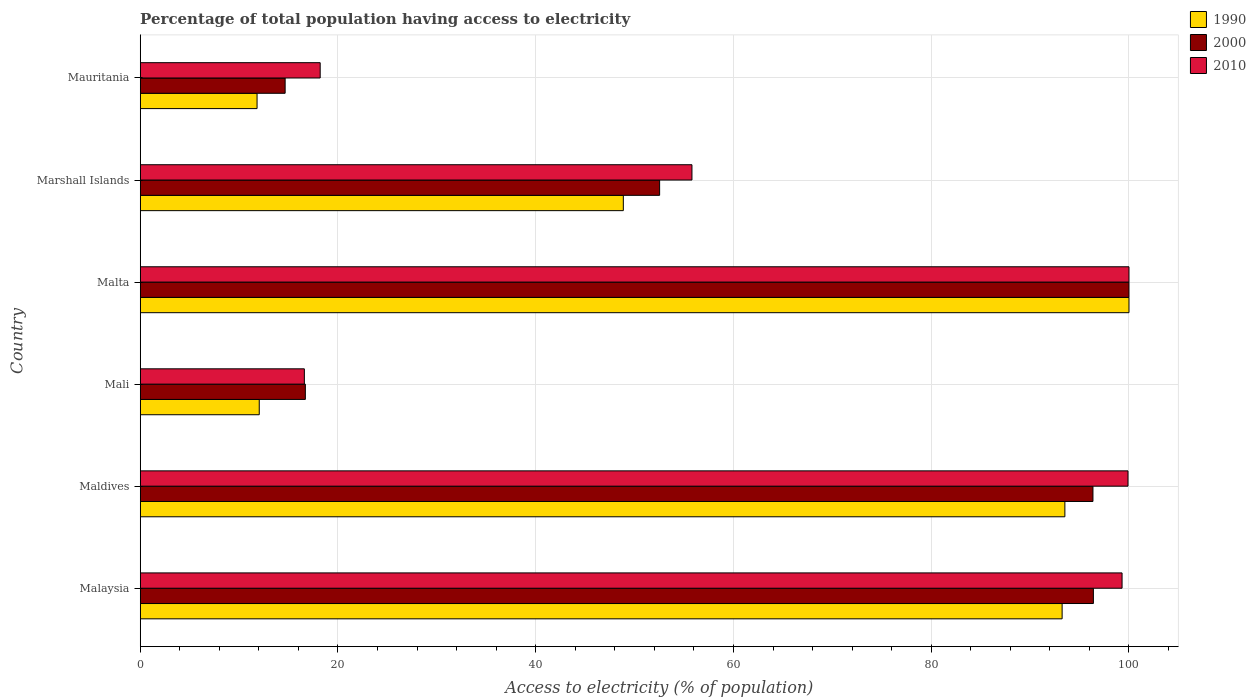What is the label of the 6th group of bars from the top?
Ensure brevity in your answer.  Malaysia. Across all countries, what is the maximum percentage of population that have access to electricity in 1990?
Your answer should be compact. 100. Across all countries, what is the minimum percentage of population that have access to electricity in 2000?
Give a very brief answer. 14.66. In which country was the percentage of population that have access to electricity in 2010 maximum?
Make the answer very short. Malta. In which country was the percentage of population that have access to electricity in 2010 minimum?
Make the answer very short. Mali. What is the total percentage of population that have access to electricity in 1990 in the graph?
Give a very brief answer. 359.47. What is the difference between the percentage of population that have access to electricity in 2010 in Marshall Islands and that in Mauritania?
Keep it short and to the point. 37.6. What is the difference between the percentage of population that have access to electricity in 2000 in Marshall Islands and the percentage of population that have access to electricity in 2010 in Maldives?
Make the answer very short. -47.37. What is the average percentage of population that have access to electricity in 2000 per country?
Make the answer very short. 62.77. What is the difference between the percentage of population that have access to electricity in 2010 and percentage of population that have access to electricity in 2000 in Malaysia?
Make the answer very short. 2.9. What is the ratio of the percentage of population that have access to electricity in 2010 in Malta to that in Marshall Islands?
Your response must be concise. 1.79. Is the difference between the percentage of population that have access to electricity in 2010 in Malta and Mauritania greater than the difference between the percentage of population that have access to electricity in 2000 in Malta and Mauritania?
Provide a succinct answer. No. What is the difference between the highest and the second highest percentage of population that have access to electricity in 1990?
Provide a short and direct response. 6.48. What is the difference between the highest and the lowest percentage of population that have access to electricity in 2000?
Ensure brevity in your answer.  85.34. In how many countries, is the percentage of population that have access to electricity in 1990 greater than the average percentage of population that have access to electricity in 1990 taken over all countries?
Your answer should be compact. 3. What does the 3rd bar from the bottom in Maldives represents?
Your answer should be very brief. 2010. Is it the case that in every country, the sum of the percentage of population that have access to electricity in 2010 and percentage of population that have access to electricity in 1990 is greater than the percentage of population that have access to electricity in 2000?
Offer a very short reply. Yes. Are all the bars in the graph horizontal?
Make the answer very short. Yes. What is the difference between two consecutive major ticks on the X-axis?
Your answer should be compact. 20. Are the values on the major ticks of X-axis written in scientific E-notation?
Make the answer very short. No. Does the graph contain grids?
Your answer should be very brief. Yes. How many legend labels are there?
Ensure brevity in your answer.  3. What is the title of the graph?
Give a very brief answer. Percentage of total population having access to electricity. What is the label or title of the X-axis?
Your answer should be very brief. Access to electricity (% of population). What is the label or title of the Y-axis?
Your response must be concise. Country. What is the Access to electricity (% of population) in 1990 in Malaysia?
Offer a very short reply. 93.24. What is the Access to electricity (% of population) of 2000 in Malaysia?
Offer a very short reply. 96.4. What is the Access to electricity (% of population) in 2010 in Malaysia?
Give a very brief answer. 99.3. What is the Access to electricity (% of population) of 1990 in Maldives?
Make the answer very short. 93.52. What is the Access to electricity (% of population) in 2000 in Maldives?
Make the answer very short. 96.36. What is the Access to electricity (% of population) of 2010 in Maldives?
Your answer should be compact. 99.9. What is the Access to electricity (% of population) of 1990 in Mali?
Offer a very short reply. 12.04. What is the Access to electricity (% of population) of 2010 in Mali?
Your answer should be very brief. 16.6. What is the Access to electricity (% of population) of 1990 in Malta?
Offer a terse response. 100. What is the Access to electricity (% of population) in 2010 in Malta?
Provide a short and direct response. 100. What is the Access to electricity (% of population) of 1990 in Marshall Islands?
Make the answer very short. 48.86. What is the Access to electricity (% of population) of 2000 in Marshall Islands?
Provide a short and direct response. 52.53. What is the Access to electricity (% of population) of 2010 in Marshall Islands?
Your answer should be compact. 55.8. What is the Access to electricity (% of population) of 1990 in Mauritania?
Make the answer very short. 11.82. What is the Access to electricity (% of population) of 2000 in Mauritania?
Ensure brevity in your answer.  14.66. Across all countries, what is the maximum Access to electricity (% of population) of 1990?
Your answer should be very brief. 100. Across all countries, what is the minimum Access to electricity (% of population) in 1990?
Give a very brief answer. 11.82. Across all countries, what is the minimum Access to electricity (% of population) in 2000?
Your answer should be very brief. 14.66. What is the total Access to electricity (% of population) of 1990 in the graph?
Ensure brevity in your answer.  359.47. What is the total Access to electricity (% of population) of 2000 in the graph?
Ensure brevity in your answer.  376.64. What is the total Access to electricity (% of population) in 2010 in the graph?
Your response must be concise. 389.8. What is the difference between the Access to electricity (% of population) of 1990 in Malaysia and that in Maldives?
Ensure brevity in your answer.  -0.28. What is the difference between the Access to electricity (% of population) of 2000 in Malaysia and that in Maldives?
Ensure brevity in your answer.  0.04. What is the difference between the Access to electricity (% of population) in 1990 in Malaysia and that in Mali?
Give a very brief answer. 81.2. What is the difference between the Access to electricity (% of population) in 2000 in Malaysia and that in Mali?
Your answer should be compact. 79.7. What is the difference between the Access to electricity (% of population) of 2010 in Malaysia and that in Mali?
Ensure brevity in your answer.  82.7. What is the difference between the Access to electricity (% of population) of 1990 in Malaysia and that in Malta?
Provide a succinct answer. -6.76. What is the difference between the Access to electricity (% of population) of 2000 in Malaysia and that in Malta?
Give a very brief answer. -3.6. What is the difference between the Access to electricity (% of population) of 2010 in Malaysia and that in Malta?
Offer a very short reply. -0.7. What is the difference between the Access to electricity (% of population) of 1990 in Malaysia and that in Marshall Islands?
Your response must be concise. 44.38. What is the difference between the Access to electricity (% of population) in 2000 in Malaysia and that in Marshall Islands?
Your answer should be compact. 43.87. What is the difference between the Access to electricity (% of population) in 2010 in Malaysia and that in Marshall Islands?
Ensure brevity in your answer.  43.5. What is the difference between the Access to electricity (% of population) in 1990 in Malaysia and that in Mauritania?
Your answer should be very brief. 81.42. What is the difference between the Access to electricity (% of population) of 2000 in Malaysia and that in Mauritania?
Make the answer very short. 81.74. What is the difference between the Access to electricity (% of population) in 2010 in Malaysia and that in Mauritania?
Make the answer very short. 81.1. What is the difference between the Access to electricity (% of population) of 1990 in Maldives and that in Mali?
Your answer should be compact. 81.48. What is the difference between the Access to electricity (% of population) of 2000 in Maldives and that in Mali?
Offer a very short reply. 79.66. What is the difference between the Access to electricity (% of population) in 2010 in Maldives and that in Mali?
Your response must be concise. 83.3. What is the difference between the Access to electricity (% of population) of 1990 in Maldives and that in Malta?
Give a very brief answer. -6.48. What is the difference between the Access to electricity (% of population) of 2000 in Maldives and that in Malta?
Offer a very short reply. -3.64. What is the difference between the Access to electricity (% of population) of 1990 in Maldives and that in Marshall Islands?
Make the answer very short. 44.66. What is the difference between the Access to electricity (% of population) of 2000 in Maldives and that in Marshall Islands?
Your response must be concise. 43.83. What is the difference between the Access to electricity (% of population) in 2010 in Maldives and that in Marshall Islands?
Give a very brief answer. 44.1. What is the difference between the Access to electricity (% of population) of 1990 in Maldives and that in Mauritania?
Your answer should be very brief. 81.7. What is the difference between the Access to electricity (% of population) of 2000 in Maldives and that in Mauritania?
Offer a very short reply. 81.7. What is the difference between the Access to electricity (% of population) of 2010 in Maldives and that in Mauritania?
Offer a terse response. 81.7. What is the difference between the Access to electricity (% of population) in 1990 in Mali and that in Malta?
Make the answer very short. -87.96. What is the difference between the Access to electricity (% of population) in 2000 in Mali and that in Malta?
Give a very brief answer. -83.3. What is the difference between the Access to electricity (% of population) of 2010 in Mali and that in Malta?
Offer a very short reply. -83.4. What is the difference between the Access to electricity (% of population) in 1990 in Mali and that in Marshall Islands?
Your response must be concise. -36.82. What is the difference between the Access to electricity (% of population) of 2000 in Mali and that in Marshall Islands?
Offer a terse response. -35.83. What is the difference between the Access to electricity (% of population) of 2010 in Mali and that in Marshall Islands?
Your answer should be compact. -39.2. What is the difference between the Access to electricity (% of population) of 1990 in Mali and that in Mauritania?
Your answer should be very brief. 0.22. What is the difference between the Access to electricity (% of population) of 2000 in Mali and that in Mauritania?
Offer a very short reply. 2.04. What is the difference between the Access to electricity (% of population) in 2010 in Mali and that in Mauritania?
Your response must be concise. -1.6. What is the difference between the Access to electricity (% of population) of 1990 in Malta and that in Marshall Islands?
Give a very brief answer. 51.14. What is the difference between the Access to electricity (% of population) of 2000 in Malta and that in Marshall Islands?
Ensure brevity in your answer.  47.47. What is the difference between the Access to electricity (% of population) in 2010 in Malta and that in Marshall Islands?
Make the answer very short. 44.2. What is the difference between the Access to electricity (% of population) in 1990 in Malta and that in Mauritania?
Your response must be concise. 88.18. What is the difference between the Access to electricity (% of population) of 2000 in Malta and that in Mauritania?
Offer a terse response. 85.34. What is the difference between the Access to electricity (% of population) in 2010 in Malta and that in Mauritania?
Keep it short and to the point. 81.8. What is the difference between the Access to electricity (% of population) in 1990 in Marshall Islands and that in Mauritania?
Keep it short and to the point. 37.04. What is the difference between the Access to electricity (% of population) in 2000 in Marshall Islands and that in Mauritania?
Make the answer very short. 37.87. What is the difference between the Access to electricity (% of population) in 2010 in Marshall Islands and that in Mauritania?
Give a very brief answer. 37.6. What is the difference between the Access to electricity (% of population) of 1990 in Malaysia and the Access to electricity (% of population) of 2000 in Maldives?
Provide a short and direct response. -3.12. What is the difference between the Access to electricity (% of population) in 1990 in Malaysia and the Access to electricity (% of population) in 2010 in Maldives?
Offer a terse response. -6.66. What is the difference between the Access to electricity (% of population) in 1990 in Malaysia and the Access to electricity (% of population) in 2000 in Mali?
Ensure brevity in your answer.  76.54. What is the difference between the Access to electricity (% of population) in 1990 in Malaysia and the Access to electricity (% of population) in 2010 in Mali?
Ensure brevity in your answer.  76.64. What is the difference between the Access to electricity (% of population) in 2000 in Malaysia and the Access to electricity (% of population) in 2010 in Mali?
Provide a short and direct response. 79.8. What is the difference between the Access to electricity (% of population) of 1990 in Malaysia and the Access to electricity (% of population) of 2000 in Malta?
Provide a succinct answer. -6.76. What is the difference between the Access to electricity (% of population) of 1990 in Malaysia and the Access to electricity (% of population) of 2010 in Malta?
Ensure brevity in your answer.  -6.76. What is the difference between the Access to electricity (% of population) in 1990 in Malaysia and the Access to electricity (% of population) in 2000 in Marshall Islands?
Provide a succinct answer. 40.71. What is the difference between the Access to electricity (% of population) of 1990 in Malaysia and the Access to electricity (% of population) of 2010 in Marshall Islands?
Provide a short and direct response. 37.44. What is the difference between the Access to electricity (% of population) of 2000 in Malaysia and the Access to electricity (% of population) of 2010 in Marshall Islands?
Offer a very short reply. 40.6. What is the difference between the Access to electricity (% of population) of 1990 in Malaysia and the Access to electricity (% of population) of 2000 in Mauritania?
Keep it short and to the point. 78.58. What is the difference between the Access to electricity (% of population) in 1990 in Malaysia and the Access to electricity (% of population) in 2010 in Mauritania?
Provide a succinct answer. 75.04. What is the difference between the Access to electricity (% of population) of 2000 in Malaysia and the Access to electricity (% of population) of 2010 in Mauritania?
Offer a very short reply. 78.2. What is the difference between the Access to electricity (% of population) in 1990 in Maldives and the Access to electricity (% of population) in 2000 in Mali?
Your response must be concise. 76.82. What is the difference between the Access to electricity (% of population) in 1990 in Maldives and the Access to electricity (% of population) in 2010 in Mali?
Provide a succinct answer. 76.92. What is the difference between the Access to electricity (% of population) of 2000 in Maldives and the Access to electricity (% of population) of 2010 in Mali?
Give a very brief answer. 79.76. What is the difference between the Access to electricity (% of population) in 1990 in Maldives and the Access to electricity (% of population) in 2000 in Malta?
Provide a short and direct response. -6.48. What is the difference between the Access to electricity (% of population) in 1990 in Maldives and the Access to electricity (% of population) in 2010 in Malta?
Offer a terse response. -6.48. What is the difference between the Access to electricity (% of population) of 2000 in Maldives and the Access to electricity (% of population) of 2010 in Malta?
Offer a terse response. -3.64. What is the difference between the Access to electricity (% of population) of 1990 in Maldives and the Access to electricity (% of population) of 2000 in Marshall Islands?
Keep it short and to the point. 40.99. What is the difference between the Access to electricity (% of population) of 1990 in Maldives and the Access to electricity (% of population) of 2010 in Marshall Islands?
Ensure brevity in your answer.  37.72. What is the difference between the Access to electricity (% of population) of 2000 in Maldives and the Access to electricity (% of population) of 2010 in Marshall Islands?
Give a very brief answer. 40.56. What is the difference between the Access to electricity (% of population) of 1990 in Maldives and the Access to electricity (% of population) of 2000 in Mauritania?
Provide a succinct answer. 78.86. What is the difference between the Access to electricity (% of population) of 1990 in Maldives and the Access to electricity (% of population) of 2010 in Mauritania?
Your response must be concise. 75.32. What is the difference between the Access to electricity (% of population) in 2000 in Maldives and the Access to electricity (% of population) in 2010 in Mauritania?
Your answer should be very brief. 78.16. What is the difference between the Access to electricity (% of population) in 1990 in Mali and the Access to electricity (% of population) in 2000 in Malta?
Make the answer very short. -87.96. What is the difference between the Access to electricity (% of population) in 1990 in Mali and the Access to electricity (% of population) in 2010 in Malta?
Make the answer very short. -87.96. What is the difference between the Access to electricity (% of population) in 2000 in Mali and the Access to electricity (% of population) in 2010 in Malta?
Your response must be concise. -83.3. What is the difference between the Access to electricity (% of population) in 1990 in Mali and the Access to electricity (% of population) in 2000 in Marshall Islands?
Your answer should be very brief. -40.49. What is the difference between the Access to electricity (% of population) of 1990 in Mali and the Access to electricity (% of population) of 2010 in Marshall Islands?
Provide a succinct answer. -43.76. What is the difference between the Access to electricity (% of population) in 2000 in Mali and the Access to electricity (% of population) in 2010 in Marshall Islands?
Your answer should be compact. -39.1. What is the difference between the Access to electricity (% of population) in 1990 in Mali and the Access to electricity (% of population) in 2000 in Mauritania?
Make the answer very short. -2.62. What is the difference between the Access to electricity (% of population) in 1990 in Mali and the Access to electricity (% of population) in 2010 in Mauritania?
Offer a terse response. -6.16. What is the difference between the Access to electricity (% of population) of 1990 in Malta and the Access to electricity (% of population) of 2000 in Marshall Islands?
Make the answer very short. 47.47. What is the difference between the Access to electricity (% of population) of 1990 in Malta and the Access to electricity (% of population) of 2010 in Marshall Islands?
Offer a terse response. 44.2. What is the difference between the Access to electricity (% of population) of 2000 in Malta and the Access to electricity (% of population) of 2010 in Marshall Islands?
Your answer should be compact. 44.2. What is the difference between the Access to electricity (% of population) in 1990 in Malta and the Access to electricity (% of population) in 2000 in Mauritania?
Your response must be concise. 85.34. What is the difference between the Access to electricity (% of population) of 1990 in Malta and the Access to electricity (% of population) of 2010 in Mauritania?
Your response must be concise. 81.8. What is the difference between the Access to electricity (% of population) of 2000 in Malta and the Access to electricity (% of population) of 2010 in Mauritania?
Offer a very short reply. 81.8. What is the difference between the Access to electricity (% of population) of 1990 in Marshall Islands and the Access to electricity (% of population) of 2000 in Mauritania?
Keep it short and to the point. 34.2. What is the difference between the Access to electricity (% of population) in 1990 in Marshall Islands and the Access to electricity (% of population) in 2010 in Mauritania?
Keep it short and to the point. 30.66. What is the difference between the Access to electricity (% of population) in 2000 in Marshall Islands and the Access to electricity (% of population) in 2010 in Mauritania?
Your answer should be compact. 34.33. What is the average Access to electricity (% of population) in 1990 per country?
Provide a succinct answer. 59.91. What is the average Access to electricity (% of population) of 2000 per country?
Your answer should be compact. 62.77. What is the average Access to electricity (% of population) of 2010 per country?
Provide a succinct answer. 64.97. What is the difference between the Access to electricity (% of population) in 1990 and Access to electricity (% of population) in 2000 in Malaysia?
Give a very brief answer. -3.16. What is the difference between the Access to electricity (% of population) in 1990 and Access to electricity (% of population) in 2010 in Malaysia?
Ensure brevity in your answer.  -6.06. What is the difference between the Access to electricity (% of population) of 2000 and Access to electricity (% of population) of 2010 in Malaysia?
Your response must be concise. -2.9. What is the difference between the Access to electricity (% of population) of 1990 and Access to electricity (% of population) of 2000 in Maldives?
Your answer should be very brief. -2.84. What is the difference between the Access to electricity (% of population) of 1990 and Access to electricity (% of population) of 2010 in Maldives?
Your answer should be compact. -6.38. What is the difference between the Access to electricity (% of population) in 2000 and Access to electricity (% of population) in 2010 in Maldives?
Provide a short and direct response. -3.54. What is the difference between the Access to electricity (% of population) in 1990 and Access to electricity (% of population) in 2000 in Mali?
Make the answer very short. -4.66. What is the difference between the Access to electricity (% of population) in 1990 and Access to electricity (% of population) in 2010 in Mali?
Provide a short and direct response. -4.56. What is the difference between the Access to electricity (% of population) in 2000 and Access to electricity (% of population) in 2010 in Mali?
Give a very brief answer. 0.1. What is the difference between the Access to electricity (% of population) in 1990 and Access to electricity (% of population) in 2000 in Malta?
Your answer should be compact. 0. What is the difference between the Access to electricity (% of population) of 1990 and Access to electricity (% of population) of 2010 in Malta?
Your answer should be very brief. 0. What is the difference between the Access to electricity (% of population) of 2000 and Access to electricity (% of population) of 2010 in Malta?
Ensure brevity in your answer.  0. What is the difference between the Access to electricity (% of population) of 1990 and Access to electricity (% of population) of 2000 in Marshall Islands?
Offer a terse response. -3.67. What is the difference between the Access to electricity (% of population) of 1990 and Access to electricity (% of population) of 2010 in Marshall Islands?
Your response must be concise. -6.94. What is the difference between the Access to electricity (% of population) in 2000 and Access to electricity (% of population) in 2010 in Marshall Islands?
Provide a short and direct response. -3.27. What is the difference between the Access to electricity (% of population) in 1990 and Access to electricity (% of population) in 2000 in Mauritania?
Your response must be concise. -2.84. What is the difference between the Access to electricity (% of population) in 1990 and Access to electricity (% of population) in 2010 in Mauritania?
Give a very brief answer. -6.38. What is the difference between the Access to electricity (% of population) of 2000 and Access to electricity (% of population) of 2010 in Mauritania?
Ensure brevity in your answer.  -3.54. What is the ratio of the Access to electricity (% of population) in 2000 in Malaysia to that in Maldives?
Keep it short and to the point. 1. What is the ratio of the Access to electricity (% of population) of 2010 in Malaysia to that in Maldives?
Keep it short and to the point. 0.99. What is the ratio of the Access to electricity (% of population) in 1990 in Malaysia to that in Mali?
Keep it short and to the point. 7.75. What is the ratio of the Access to electricity (% of population) in 2000 in Malaysia to that in Mali?
Provide a short and direct response. 5.77. What is the ratio of the Access to electricity (% of population) in 2010 in Malaysia to that in Mali?
Provide a short and direct response. 5.98. What is the ratio of the Access to electricity (% of population) in 1990 in Malaysia to that in Malta?
Your response must be concise. 0.93. What is the ratio of the Access to electricity (% of population) in 1990 in Malaysia to that in Marshall Islands?
Ensure brevity in your answer.  1.91. What is the ratio of the Access to electricity (% of population) of 2000 in Malaysia to that in Marshall Islands?
Offer a terse response. 1.84. What is the ratio of the Access to electricity (% of population) in 2010 in Malaysia to that in Marshall Islands?
Make the answer very short. 1.78. What is the ratio of the Access to electricity (% of population) of 1990 in Malaysia to that in Mauritania?
Provide a short and direct response. 7.89. What is the ratio of the Access to electricity (% of population) of 2000 in Malaysia to that in Mauritania?
Offer a very short reply. 6.58. What is the ratio of the Access to electricity (% of population) in 2010 in Malaysia to that in Mauritania?
Your answer should be compact. 5.46. What is the ratio of the Access to electricity (% of population) in 1990 in Maldives to that in Mali?
Offer a very short reply. 7.77. What is the ratio of the Access to electricity (% of population) in 2000 in Maldives to that in Mali?
Provide a succinct answer. 5.77. What is the ratio of the Access to electricity (% of population) of 2010 in Maldives to that in Mali?
Give a very brief answer. 6.02. What is the ratio of the Access to electricity (% of population) in 1990 in Maldives to that in Malta?
Give a very brief answer. 0.94. What is the ratio of the Access to electricity (% of population) in 2000 in Maldives to that in Malta?
Offer a very short reply. 0.96. What is the ratio of the Access to electricity (% of population) in 2010 in Maldives to that in Malta?
Offer a terse response. 1. What is the ratio of the Access to electricity (% of population) in 1990 in Maldives to that in Marshall Islands?
Provide a succinct answer. 1.91. What is the ratio of the Access to electricity (% of population) of 2000 in Maldives to that in Marshall Islands?
Offer a very short reply. 1.83. What is the ratio of the Access to electricity (% of population) in 2010 in Maldives to that in Marshall Islands?
Offer a terse response. 1.79. What is the ratio of the Access to electricity (% of population) in 1990 in Maldives to that in Mauritania?
Your answer should be compact. 7.91. What is the ratio of the Access to electricity (% of population) in 2000 in Maldives to that in Mauritania?
Give a very brief answer. 6.57. What is the ratio of the Access to electricity (% of population) in 2010 in Maldives to that in Mauritania?
Your answer should be very brief. 5.49. What is the ratio of the Access to electricity (% of population) of 1990 in Mali to that in Malta?
Offer a very short reply. 0.12. What is the ratio of the Access to electricity (% of population) in 2000 in Mali to that in Malta?
Your answer should be compact. 0.17. What is the ratio of the Access to electricity (% of population) of 2010 in Mali to that in Malta?
Your answer should be very brief. 0.17. What is the ratio of the Access to electricity (% of population) in 1990 in Mali to that in Marshall Islands?
Make the answer very short. 0.25. What is the ratio of the Access to electricity (% of population) of 2000 in Mali to that in Marshall Islands?
Ensure brevity in your answer.  0.32. What is the ratio of the Access to electricity (% of population) in 2010 in Mali to that in Marshall Islands?
Give a very brief answer. 0.3. What is the ratio of the Access to electricity (% of population) of 1990 in Mali to that in Mauritania?
Provide a succinct answer. 1.02. What is the ratio of the Access to electricity (% of population) of 2000 in Mali to that in Mauritania?
Your answer should be very brief. 1.14. What is the ratio of the Access to electricity (% of population) in 2010 in Mali to that in Mauritania?
Offer a terse response. 0.91. What is the ratio of the Access to electricity (% of population) of 1990 in Malta to that in Marshall Islands?
Provide a short and direct response. 2.05. What is the ratio of the Access to electricity (% of population) in 2000 in Malta to that in Marshall Islands?
Ensure brevity in your answer.  1.9. What is the ratio of the Access to electricity (% of population) in 2010 in Malta to that in Marshall Islands?
Your response must be concise. 1.79. What is the ratio of the Access to electricity (% of population) of 1990 in Malta to that in Mauritania?
Offer a very short reply. 8.46. What is the ratio of the Access to electricity (% of population) of 2000 in Malta to that in Mauritania?
Offer a terse response. 6.82. What is the ratio of the Access to electricity (% of population) of 2010 in Malta to that in Mauritania?
Offer a very short reply. 5.49. What is the ratio of the Access to electricity (% of population) in 1990 in Marshall Islands to that in Mauritania?
Your answer should be compact. 4.14. What is the ratio of the Access to electricity (% of population) in 2000 in Marshall Islands to that in Mauritania?
Keep it short and to the point. 3.58. What is the ratio of the Access to electricity (% of population) of 2010 in Marshall Islands to that in Mauritania?
Provide a succinct answer. 3.07. What is the difference between the highest and the second highest Access to electricity (% of population) of 1990?
Your response must be concise. 6.48. What is the difference between the highest and the second highest Access to electricity (% of population) of 2010?
Make the answer very short. 0.1. What is the difference between the highest and the lowest Access to electricity (% of population) in 1990?
Keep it short and to the point. 88.18. What is the difference between the highest and the lowest Access to electricity (% of population) in 2000?
Make the answer very short. 85.34. What is the difference between the highest and the lowest Access to electricity (% of population) in 2010?
Make the answer very short. 83.4. 